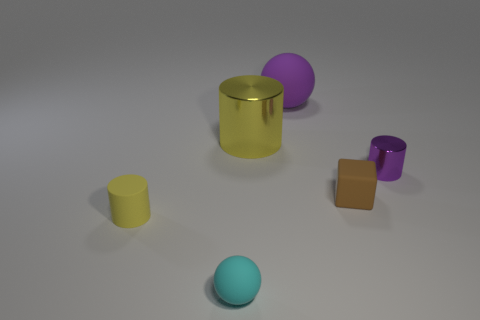Is there any other thing that has the same size as the cyan sphere? Based on the provided image, it is not possible to determine with absolute certainty if anything is exactly the same size as the cyan sphere without precise measurements. However, visually comparing the objects, none of them appear to be the exact same size as the cyan sphere. Each object has distinct dimensions that differ from that of the cyan sphere. 